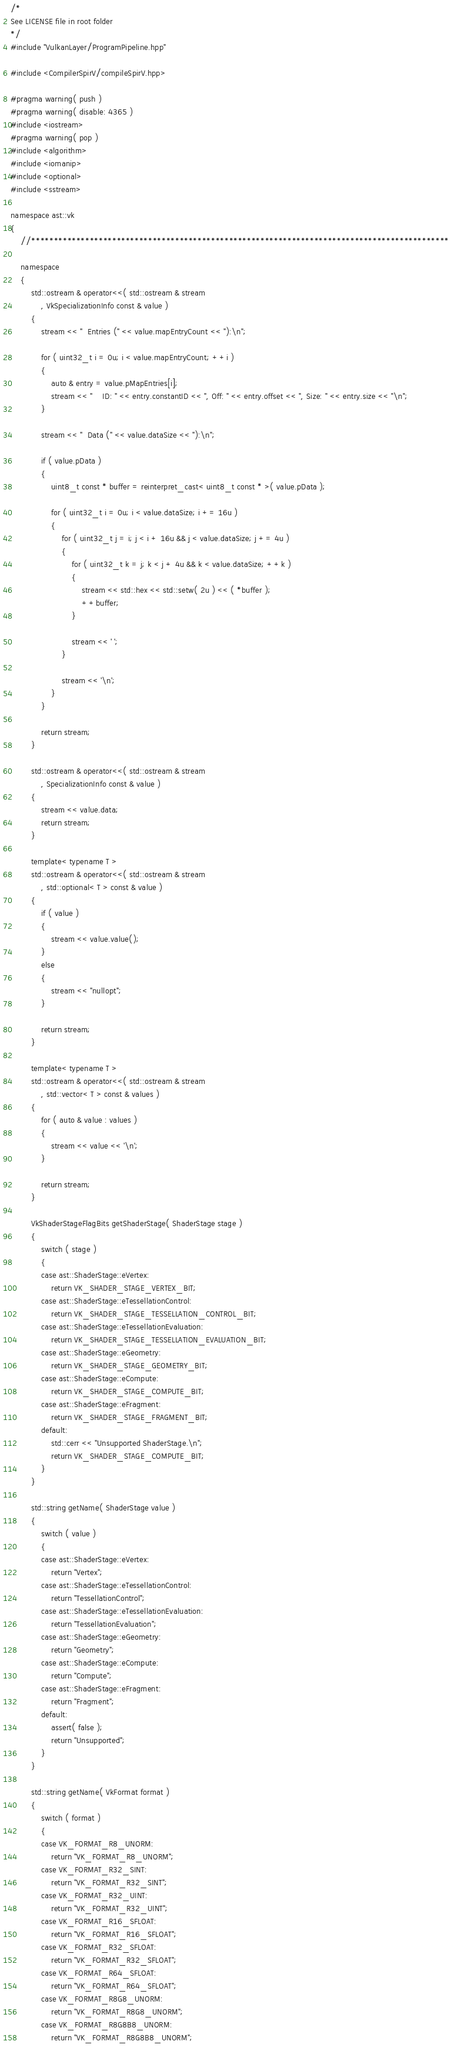Convert code to text. <code><loc_0><loc_0><loc_500><loc_500><_C++_>/*
See LICENSE file in root folder
*/
#include "VulkanLayer/ProgramPipeline.hpp"

#include <CompilerSpirV/compileSpirV.hpp>

#pragma warning( push )
#pragma warning( disable: 4365 )
#include <iostream>
#pragma warning( pop )
#include <algorithm>
#include <iomanip>
#include <optional>
#include <sstream>

namespace ast::vk
{
	//*********************************************************************************************

	namespace
	{
		std::ostream & operator<<( std::ostream & stream
			, VkSpecializationInfo const & value )
		{
			stream << "  Entries (" << value.mapEntryCount << "):\n";

			for ( uint32_t i = 0u; i < value.mapEntryCount; ++i )
			{
				auto & entry = value.pMapEntries[i];
				stream << "    ID: " << entry.constantID << ", Off: " << entry.offset << ", Size: " << entry.size << "\n";
			}

			stream << "  Data (" << value.dataSize << "):\n";

			if ( value.pData )
			{
				uint8_t const * buffer = reinterpret_cast< uint8_t const * >( value.pData );

				for ( uint32_t i = 0u; i < value.dataSize; i += 16u )
				{
					for ( uint32_t j = i; j < i + 16u && j < value.dataSize; j += 4u )
					{
						for ( uint32_t k = j; k < j + 4u && k < value.dataSize; ++k )
						{
							stream << std::hex << std::setw( 2u ) << ( *buffer );
							++buffer;
						}

						stream << ' ';
					}

					stream << '\n';
				}
			}

			return stream;
		}

		std::ostream & operator<<( std::ostream & stream
			, SpecializationInfo const & value )
		{
			stream << value.data;
			return stream;
		}

		template< typename T >
		std::ostream & operator<<( std::ostream & stream
			, std::optional< T > const & value )
		{
			if ( value )
			{
				stream << value.value();
			}
			else
			{
				stream << "nullopt";
			}

			return stream;
		}

		template< typename T >
		std::ostream & operator<<( std::ostream & stream
			, std::vector< T > const & values )
		{
			for ( auto & value : values )
			{
				stream << value << '\n';
			}

			return stream;
		}

		VkShaderStageFlagBits getShaderStage( ShaderStage stage )
		{
			switch ( stage )
			{
			case ast::ShaderStage::eVertex:
				return VK_SHADER_STAGE_VERTEX_BIT;
			case ast::ShaderStage::eTessellationControl:
				return VK_SHADER_STAGE_TESSELLATION_CONTROL_BIT;
			case ast::ShaderStage::eTessellationEvaluation:
				return VK_SHADER_STAGE_TESSELLATION_EVALUATION_BIT;
			case ast::ShaderStage::eGeometry:
				return VK_SHADER_STAGE_GEOMETRY_BIT;
			case ast::ShaderStage::eCompute:
				return VK_SHADER_STAGE_COMPUTE_BIT;
			case ast::ShaderStage::eFragment:
				return VK_SHADER_STAGE_FRAGMENT_BIT;
			default:
				std::cerr << "Unsupported ShaderStage.\n";
				return VK_SHADER_STAGE_COMPUTE_BIT;
			}
		}

		std::string getName( ShaderStage value )
		{
			switch ( value )
			{
			case ast::ShaderStage::eVertex:
				return "Vertex";
			case ast::ShaderStage::eTessellationControl:
				return "TessellationControl";
			case ast::ShaderStage::eTessellationEvaluation:
				return "TessellationEvaluation";
			case ast::ShaderStage::eGeometry:
				return "Geometry";
			case ast::ShaderStage::eCompute:
				return "Compute";
			case ast::ShaderStage::eFragment:
				return "Fragment";
			default:
				assert( false );
				return "Unsupported";
			}
		}

		std::string getName( VkFormat format )
		{
			switch ( format )
			{
			case VK_FORMAT_R8_UNORM:
				return "VK_FORMAT_R8_UNORM";
			case VK_FORMAT_R32_SINT:
				return "VK_FORMAT_R32_SINT";
			case VK_FORMAT_R32_UINT:
				return "VK_FORMAT_R32_UINT";
			case VK_FORMAT_R16_SFLOAT:
				return "VK_FORMAT_R16_SFLOAT";
			case VK_FORMAT_R32_SFLOAT:
				return "VK_FORMAT_R32_SFLOAT";
			case VK_FORMAT_R64_SFLOAT:
				return "VK_FORMAT_R64_SFLOAT";
			case VK_FORMAT_R8G8_UNORM:
				return "VK_FORMAT_R8G8_UNORM";
			case VK_FORMAT_R8G8B8_UNORM:
				return "VK_FORMAT_R8G8B8_UNORM";</code> 